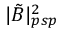<formula> <loc_0><loc_0><loc_500><loc_500>| \tilde { B } | _ { p s p } ^ { 2 }</formula> 